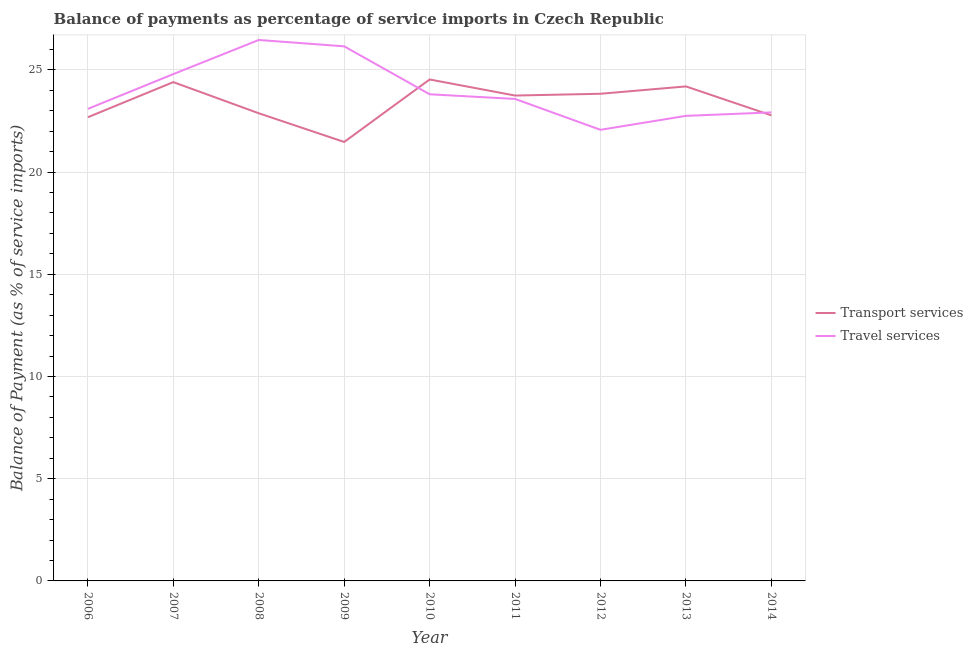How many different coloured lines are there?
Your answer should be compact. 2. Does the line corresponding to balance of payments of travel services intersect with the line corresponding to balance of payments of transport services?
Your answer should be compact. Yes. What is the balance of payments of travel services in 2010?
Your answer should be very brief. 23.8. Across all years, what is the maximum balance of payments of travel services?
Ensure brevity in your answer.  26.46. Across all years, what is the minimum balance of payments of travel services?
Provide a short and direct response. 22.07. What is the total balance of payments of travel services in the graph?
Your answer should be compact. 215.6. What is the difference between the balance of payments of travel services in 2008 and that in 2013?
Provide a short and direct response. 3.71. What is the difference between the balance of payments of transport services in 2012 and the balance of payments of travel services in 2011?
Offer a very short reply. 0.25. What is the average balance of payments of travel services per year?
Your answer should be compact. 23.96. In the year 2011, what is the difference between the balance of payments of travel services and balance of payments of transport services?
Provide a short and direct response. -0.17. In how many years, is the balance of payments of travel services greater than 24 %?
Offer a terse response. 3. What is the ratio of the balance of payments of transport services in 2007 to that in 2009?
Your answer should be compact. 1.14. Is the balance of payments of transport services in 2010 less than that in 2012?
Your response must be concise. No. Is the difference between the balance of payments of transport services in 2006 and 2008 greater than the difference between the balance of payments of travel services in 2006 and 2008?
Give a very brief answer. Yes. What is the difference between the highest and the second highest balance of payments of travel services?
Keep it short and to the point. 0.31. What is the difference between the highest and the lowest balance of payments of travel services?
Provide a short and direct response. 4.39. In how many years, is the balance of payments of transport services greater than the average balance of payments of transport services taken over all years?
Keep it short and to the point. 5. How many lines are there?
Your answer should be very brief. 2. How many years are there in the graph?
Keep it short and to the point. 9. What is the difference between two consecutive major ticks on the Y-axis?
Ensure brevity in your answer.  5. Are the values on the major ticks of Y-axis written in scientific E-notation?
Offer a very short reply. No. Does the graph contain grids?
Your response must be concise. Yes. Where does the legend appear in the graph?
Make the answer very short. Center right. How many legend labels are there?
Ensure brevity in your answer.  2. How are the legend labels stacked?
Your response must be concise. Vertical. What is the title of the graph?
Your response must be concise. Balance of payments as percentage of service imports in Czech Republic. Does "Quality of trade" appear as one of the legend labels in the graph?
Provide a short and direct response. No. What is the label or title of the Y-axis?
Give a very brief answer. Balance of Payment (as % of service imports). What is the Balance of Payment (as % of service imports) of Transport services in 2006?
Give a very brief answer. 22.68. What is the Balance of Payment (as % of service imports) of Travel services in 2006?
Offer a terse response. 23.09. What is the Balance of Payment (as % of service imports) of Transport services in 2007?
Keep it short and to the point. 24.4. What is the Balance of Payment (as % of service imports) in Travel services in 2007?
Make the answer very short. 24.79. What is the Balance of Payment (as % of service imports) of Transport services in 2008?
Offer a very short reply. 22.88. What is the Balance of Payment (as % of service imports) in Travel services in 2008?
Offer a terse response. 26.46. What is the Balance of Payment (as % of service imports) in Transport services in 2009?
Provide a succinct answer. 21.47. What is the Balance of Payment (as % of service imports) of Travel services in 2009?
Make the answer very short. 26.15. What is the Balance of Payment (as % of service imports) of Transport services in 2010?
Provide a succinct answer. 24.53. What is the Balance of Payment (as % of service imports) of Travel services in 2010?
Your answer should be compact. 23.8. What is the Balance of Payment (as % of service imports) of Transport services in 2011?
Make the answer very short. 23.74. What is the Balance of Payment (as % of service imports) in Travel services in 2011?
Make the answer very short. 23.58. What is the Balance of Payment (as % of service imports) in Transport services in 2012?
Keep it short and to the point. 23.83. What is the Balance of Payment (as % of service imports) in Travel services in 2012?
Make the answer very short. 22.07. What is the Balance of Payment (as % of service imports) in Transport services in 2013?
Make the answer very short. 24.19. What is the Balance of Payment (as % of service imports) in Travel services in 2013?
Your answer should be compact. 22.75. What is the Balance of Payment (as % of service imports) in Transport services in 2014?
Your answer should be compact. 22.77. What is the Balance of Payment (as % of service imports) in Travel services in 2014?
Make the answer very short. 22.92. Across all years, what is the maximum Balance of Payment (as % of service imports) in Transport services?
Offer a terse response. 24.53. Across all years, what is the maximum Balance of Payment (as % of service imports) of Travel services?
Keep it short and to the point. 26.46. Across all years, what is the minimum Balance of Payment (as % of service imports) in Transport services?
Ensure brevity in your answer.  21.47. Across all years, what is the minimum Balance of Payment (as % of service imports) in Travel services?
Your response must be concise. 22.07. What is the total Balance of Payment (as % of service imports) of Transport services in the graph?
Your response must be concise. 210.49. What is the total Balance of Payment (as % of service imports) of Travel services in the graph?
Give a very brief answer. 215.6. What is the difference between the Balance of Payment (as % of service imports) in Transport services in 2006 and that in 2007?
Offer a very short reply. -1.72. What is the difference between the Balance of Payment (as % of service imports) in Travel services in 2006 and that in 2007?
Offer a terse response. -1.7. What is the difference between the Balance of Payment (as % of service imports) of Transport services in 2006 and that in 2008?
Provide a short and direct response. -0.19. What is the difference between the Balance of Payment (as % of service imports) in Travel services in 2006 and that in 2008?
Give a very brief answer. -3.37. What is the difference between the Balance of Payment (as % of service imports) in Transport services in 2006 and that in 2009?
Your response must be concise. 1.21. What is the difference between the Balance of Payment (as % of service imports) in Travel services in 2006 and that in 2009?
Ensure brevity in your answer.  -3.06. What is the difference between the Balance of Payment (as % of service imports) in Transport services in 2006 and that in 2010?
Keep it short and to the point. -1.84. What is the difference between the Balance of Payment (as % of service imports) of Travel services in 2006 and that in 2010?
Make the answer very short. -0.71. What is the difference between the Balance of Payment (as % of service imports) in Transport services in 2006 and that in 2011?
Ensure brevity in your answer.  -1.06. What is the difference between the Balance of Payment (as % of service imports) of Travel services in 2006 and that in 2011?
Your answer should be very brief. -0.49. What is the difference between the Balance of Payment (as % of service imports) in Transport services in 2006 and that in 2012?
Ensure brevity in your answer.  -1.15. What is the difference between the Balance of Payment (as % of service imports) in Travel services in 2006 and that in 2012?
Keep it short and to the point. 1.02. What is the difference between the Balance of Payment (as % of service imports) of Transport services in 2006 and that in 2013?
Provide a short and direct response. -1.51. What is the difference between the Balance of Payment (as % of service imports) in Travel services in 2006 and that in 2013?
Offer a terse response. 0.34. What is the difference between the Balance of Payment (as % of service imports) in Transport services in 2006 and that in 2014?
Your answer should be compact. -0.09. What is the difference between the Balance of Payment (as % of service imports) of Travel services in 2006 and that in 2014?
Keep it short and to the point. 0.17. What is the difference between the Balance of Payment (as % of service imports) of Transport services in 2007 and that in 2008?
Ensure brevity in your answer.  1.52. What is the difference between the Balance of Payment (as % of service imports) of Travel services in 2007 and that in 2008?
Your response must be concise. -1.67. What is the difference between the Balance of Payment (as % of service imports) of Transport services in 2007 and that in 2009?
Your answer should be very brief. 2.93. What is the difference between the Balance of Payment (as % of service imports) of Travel services in 2007 and that in 2009?
Offer a terse response. -1.36. What is the difference between the Balance of Payment (as % of service imports) of Transport services in 2007 and that in 2010?
Make the answer very short. -0.13. What is the difference between the Balance of Payment (as % of service imports) in Travel services in 2007 and that in 2010?
Your answer should be very brief. 0.99. What is the difference between the Balance of Payment (as % of service imports) of Transport services in 2007 and that in 2011?
Your response must be concise. 0.66. What is the difference between the Balance of Payment (as % of service imports) in Travel services in 2007 and that in 2011?
Keep it short and to the point. 1.21. What is the difference between the Balance of Payment (as % of service imports) of Transport services in 2007 and that in 2012?
Keep it short and to the point. 0.57. What is the difference between the Balance of Payment (as % of service imports) in Travel services in 2007 and that in 2012?
Keep it short and to the point. 2.73. What is the difference between the Balance of Payment (as % of service imports) in Transport services in 2007 and that in 2013?
Provide a short and direct response. 0.21. What is the difference between the Balance of Payment (as % of service imports) of Travel services in 2007 and that in 2013?
Ensure brevity in your answer.  2.04. What is the difference between the Balance of Payment (as % of service imports) in Transport services in 2007 and that in 2014?
Make the answer very short. 1.63. What is the difference between the Balance of Payment (as % of service imports) in Travel services in 2007 and that in 2014?
Give a very brief answer. 1.87. What is the difference between the Balance of Payment (as % of service imports) of Transport services in 2008 and that in 2009?
Keep it short and to the point. 1.4. What is the difference between the Balance of Payment (as % of service imports) in Travel services in 2008 and that in 2009?
Keep it short and to the point. 0.31. What is the difference between the Balance of Payment (as % of service imports) of Transport services in 2008 and that in 2010?
Offer a terse response. -1.65. What is the difference between the Balance of Payment (as % of service imports) of Travel services in 2008 and that in 2010?
Provide a short and direct response. 2.66. What is the difference between the Balance of Payment (as % of service imports) in Transport services in 2008 and that in 2011?
Give a very brief answer. -0.87. What is the difference between the Balance of Payment (as % of service imports) of Travel services in 2008 and that in 2011?
Your answer should be compact. 2.88. What is the difference between the Balance of Payment (as % of service imports) of Transport services in 2008 and that in 2012?
Provide a succinct answer. -0.95. What is the difference between the Balance of Payment (as % of service imports) in Travel services in 2008 and that in 2012?
Offer a terse response. 4.39. What is the difference between the Balance of Payment (as % of service imports) in Transport services in 2008 and that in 2013?
Ensure brevity in your answer.  -1.31. What is the difference between the Balance of Payment (as % of service imports) in Travel services in 2008 and that in 2013?
Keep it short and to the point. 3.71. What is the difference between the Balance of Payment (as % of service imports) of Transport services in 2008 and that in 2014?
Offer a very short reply. 0.1. What is the difference between the Balance of Payment (as % of service imports) of Travel services in 2008 and that in 2014?
Your response must be concise. 3.54. What is the difference between the Balance of Payment (as % of service imports) of Transport services in 2009 and that in 2010?
Your answer should be very brief. -3.06. What is the difference between the Balance of Payment (as % of service imports) in Travel services in 2009 and that in 2010?
Your answer should be very brief. 2.34. What is the difference between the Balance of Payment (as % of service imports) in Transport services in 2009 and that in 2011?
Your answer should be very brief. -2.27. What is the difference between the Balance of Payment (as % of service imports) in Travel services in 2009 and that in 2011?
Offer a very short reply. 2.57. What is the difference between the Balance of Payment (as % of service imports) in Transport services in 2009 and that in 2012?
Your answer should be very brief. -2.36. What is the difference between the Balance of Payment (as % of service imports) of Travel services in 2009 and that in 2012?
Your response must be concise. 4.08. What is the difference between the Balance of Payment (as % of service imports) in Transport services in 2009 and that in 2013?
Provide a short and direct response. -2.72. What is the difference between the Balance of Payment (as % of service imports) of Travel services in 2009 and that in 2013?
Offer a very short reply. 3.4. What is the difference between the Balance of Payment (as % of service imports) of Transport services in 2009 and that in 2014?
Your response must be concise. -1.3. What is the difference between the Balance of Payment (as % of service imports) of Travel services in 2009 and that in 2014?
Offer a very short reply. 3.23. What is the difference between the Balance of Payment (as % of service imports) in Transport services in 2010 and that in 2011?
Ensure brevity in your answer.  0.79. What is the difference between the Balance of Payment (as % of service imports) in Travel services in 2010 and that in 2011?
Give a very brief answer. 0.23. What is the difference between the Balance of Payment (as % of service imports) of Transport services in 2010 and that in 2012?
Ensure brevity in your answer.  0.7. What is the difference between the Balance of Payment (as % of service imports) in Travel services in 2010 and that in 2012?
Offer a very short reply. 1.74. What is the difference between the Balance of Payment (as % of service imports) in Transport services in 2010 and that in 2013?
Provide a short and direct response. 0.34. What is the difference between the Balance of Payment (as % of service imports) of Travel services in 2010 and that in 2013?
Provide a short and direct response. 1.06. What is the difference between the Balance of Payment (as % of service imports) in Transport services in 2010 and that in 2014?
Your answer should be compact. 1.75. What is the difference between the Balance of Payment (as % of service imports) of Travel services in 2010 and that in 2014?
Give a very brief answer. 0.89. What is the difference between the Balance of Payment (as % of service imports) of Transport services in 2011 and that in 2012?
Your answer should be very brief. -0.09. What is the difference between the Balance of Payment (as % of service imports) in Travel services in 2011 and that in 2012?
Make the answer very short. 1.51. What is the difference between the Balance of Payment (as % of service imports) of Transport services in 2011 and that in 2013?
Provide a succinct answer. -0.45. What is the difference between the Balance of Payment (as % of service imports) of Travel services in 2011 and that in 2013?
Provide a short and direct response. 0.83. What is the difference between the Balance of Payment (as % of service imports) of Transport services in 2011 and that in 2014?
Your answer should be compact. 0.97. What is the difference between the Balance of Payment (as % of service imports) in Travel services in 2011 and that in 2014?
Keep it short and to the point. 0.66. What is the difference between the Balance of Payment (as % of service imports) of Transport services in 2012 and that in 2013?
Give a very brief answer. -0.36. What is the difference between the Balance of Payment (as % of service imports) in Travel services in 2012 and that in 2013?
Make the answer very short. -0.68. What is the difference between the Balance of Payment (as % of service imports) in Transport services in 2012 and that in 2014?
Provide a short and direct response. 1.06. What is the difference between the Balance of Payment (as % of service imports) of Travel services in 2012 and that in 2014?
Ensure brevity in your answer.  -0.85. What is the difference between the Balance of Payment (as % of service imports) of Transport services in 2013 and that in 2014?
Your answer should be compact. 1.42. What is the difference between the Balance of Payment (as % of service imports) of Travel services in 2013 and that in 2014?
Offer a very short reply. -0.17. What is the difference between the Balance of Payment (as % of service imports) in Transport services in 2006 and the Balance of Payment (as % of service imports) in Travel services in 2007?
Your response must be concise. -2.11. What is the difference between the Balance of Payment (as % of service imports) in Transport services in 2006 and the Balance of Payment (as % of service imports) in Travel services in 2008?
Offer a terse response. -3.78. What is the difference between the Balance of Payment (as % of service imports) of Transport services in 2006 and the Balance of Payment (as % of service imports) of Travel services in 2009?
Your answer should be compact. -3.47. What is the difference between the Balance of Payment (as % of service imports) of Transport services in 2006 and the Balance of Payment (as % of service imports) of Travel services in 2010?
Offer a very short reply. -1.12. What is the difference between the Balance of Payment (as % of service imports) of Transport services in 2006 and the Balance of Payment (as % of service imports) of Travel services in 2011?
Your answer should be very brief. -0.89. What is the difference between the Balance of Payment (as % of service imports) of Transport services in 2006 and the Balance of Payment (as % of service imports) of Travel services in 2012?
Your response must be concise. 0.62. What is the difference between the Balance of Payment (as % of service imports) of Transport services in 2006 and the Balance of Payment (as % of service imports) of Travel services in 2013?
Your response must be concise. -0.07. What is the difference between the Balance of Payment (as % of service imports) of Transport services in 2006 and the Balance of Payment (as % of service imports) of Travel services in 2014?
Ensure brevity in your answer.  -0.23. What is the difference between the Balance of Payment (as % of service imports) of Transport services in 2007 and the Balance of Payment (as % of service imports) of Travel services in 2008?
Keep it short and to the point. -2.06. What is the difference between the Balance of Payment (as % of service imports) of Transport services in 2007 and the Balance of Payment (as % of service imports) of Travel services in 2009?
Make the answer very short. -1.75. What is the difference between the Balance of Payment (as % of service imports) of Transport services in 2007 and the Balance of Payment (as % of service imports) of Travel services in 2010?
Keep it short and to the point. 0.59. What is the difference between the Balance of Payment (as % of service imports) in Transport services in 2007 and the Balance of Payment (as % of service imports) in Travel services in 2011?
Provide a succinct answer. 0.82. What is the difference between the Balance of Payment (as % of service imports) of Transport services in 2007 and the Balance of Payment (as % of service imports) of Travel services in 2012?
Provide a short and direct response. 2.33. What is the difference between the Balance of Payment (as % of service imports) of Transport services in 2007 and the Balance of Payment (as % of service imports) of Travel services in 2013?
Your answer should be very brief. 1.65. What is the difference between the Balance of Payment (as % of service imports) of Transport services in 2007 and the Balance of Payment (as % of service imports) of Travel services in 2014?
Keep it short and to the point. 1.48. What is the difference between the Balance of Payment (as % of service imports) of Transport services in 2008 and the Balance of Payment (as % of service imports) of Travel services in 2009?
Your answer should be very brief. -3.27. What is the difference between the Balance of Payment (as % of service imports) of Transport services in 2008 and the Balance of Payment (as % of service imports) of Travel services in 2010?
Your answer should be compact. -0.93. What is the difference between the Balance of Payment (as % of service imports) of Transport services in 2008 and the Balance of Payment (as % of service imports) of Travel services in 2011?
Provide a succinct answer. -0.7. What is the difference between the Balance of Payment (as % of service imports) in Transport services in 2008 and the Balance of Payment (as % of service imports) in Travel services in 2012?
Ensure brevity in your answer.  0.81. What is the difference between the Balance of Payment (as % of service imports) in Transport services in 2008 and the Balance of Payment (as % of service imports) in Travel services in 2013?
Provide a succinct answer. 0.13. What is the difference between the Balance of Payment (as % of service imports) in Transport services in 2008 and the Balance of Payment (as % of service imports) in Travel services in 2014?
Provide a short and direct response. -0.04. What is the difference between the Balance of Payment (as % of service imports) of Transport services in 2009 and the Balance of Payment (as % of service imports) of Travel services in 2010?
Offer a terse response. -2.33. What is the difference between the Balance of Payment (as % of service imports) in Transport services in 2009 and the Balance of Payment (as % of service imports) in Travel services in 2011?
Provide a succinct answer. -2.11. What is the difference between the Balance of Payment (as % of service imports) in Transport services in 2009 and the Balance of Payment (as % of service imports) in Travel services in 2012?
Keep it short and to the point. -0.59. What is the difference between the Balance of Payment (as % of service imports) in Transport services in 2009 and the Balance of Payment (as % of service imports) in Travel services in 2013?
Offer a very short reply. -1.28. What is the difference between the Balance of Payment (as % of service imports) of Transport services in 2009 and the Balance of Payment (as % of service imports) of Travel services in 2014?
Your response must be concise. -1.45. What is the difference between the Balance of Payment (as % of service imports) of Transport services in 2010 and the Balance of Payment (as % of service imports) of Travel services in 2011?
Provide a succinct answer. 0.95. What is the difference between the Balance of Payment (as % of service imports) in Transport services in 2010 and the Balance of Payment (as % of service imports) in Travel services in 2012?
Your answer should be compact. 2.46. What is the difference between the Balance of Payment (as % of service imports) of Transport services in 2010 and the Balance of Payment (as % of service imports) of Travel services in 2013?
Your response must be concise. 1.78. What is the difference between the Balance of Payment (as % of service imports) of Transport services in 2010 and the Balance of Payment (as % of service imports) of Travel services in 2014?
Give a very brief answer. 1.61. What is the difference between the Balance of Payment (as % of service imports) of Transport services in 2011 and the Balance of Payment (as % of service imports) of Travel services in 2012?
Your response must be concise. 1.68. What is the difference between the Balance of Payment (as % of service imports) in Transport services in 2011 and the Balance of Payment (as % of service imports) in Travel services in 2013?
Provide a succinct answer. 0.99. What is the difference between the Balance of Payment (as % of service imports) in Transport services in 2011 and the Balance of Payment (as % of service imports) in Travel services in 2014?
Give a very brief answer. 0.82. What is the difference between the Balance of Payment (as % of service imports) of Transport services in 2012 and the Balance of Payment (as % of service imports) of Travel services in 2013?
Keep it short and to the point. 1.08. What is the difference between the Balance of Payment (as % of service imports) of Transport services in 2012 and the Balance of Payment (as % of service imports) of Travel services in 2014?
Your answer should be very brief. 0.91. What is the difference between the Balance of Payment (as % of service imports) of Transport services in 2013 and the Balance of Payment (as % of service imports) of Travel services in 2014?
Ensure brevity in your answer.  1.27. What is the average Balance of Payment (as % of service imports) of Transport services per year?
Ensure brevity in your answer.  23.39. What is the average Balance of Payment (as % of service imports) in Travel services per year?
Offer a very short reply. 23.96. In the year 2006, what is the difference between the Balance of Payment (as % of service imports) of Transport services and Balance of Payment (as % of service imports) of Travel services?
Offer a very short reply. -0.41. In the year 2007, what is the difference between the Balance of Payment (as % of service imports) of Transport services and Balance of Payment (as % of service imports) of Travel services?
Ensure brevity in your answer.  -0.39. In the year 2008, what is the difference between the Balance of Payment (as % of service imports) in Transport services and Balance of Payment (as % of service imports) in Travel services?
Ensure brevity in your answer.  -3.58. In the year 2009, what is the difference between the Balance of Payment (as % of service imports) of Transport services and Balance of Payment (as % of service imports) of Travel services?
Provide a short and direct response. -4.68. In the year 2010, what is the difference between the Balance of Payment (as % of service imports) of Transport services and Balance of Payment (as % of service imports) of Travel services?
Offer a terse response. 0.72. In the year 2011, what is the difference between the Balance of Payment (as % of service imports) of Transport services and Balance of Payment (as % of service imports) of Travel services?
Keep it short and to the point. 0.17. In the year 2012, what is the difference between the Balance of Payment (as % of service imports) of Transport services and Balance of Payment (as % of service imports) of Travel services?
Your response must be concise. 1.76. In the year 2013, what is the difference between the Balance of Payment (as % of service imports) in Transport services and Balance of Payment (as % of service imports) in Travel services?
Ensure brevity in your answer.  1.44. In the year 2014, what is the difference between the Balance of Payment (as % of service imports) in Transport services and Balance of Payment (as % of service imports) in Travel services?
Make the answer very short. -0.14. What is the ratio of the Balance of Payment (as % of service imports) in Transport services in 2006 to that in 2007?
Ensure brevity in your answer.  0.93. What is the ratio of the Balance of Payment (as % of service imports) in Travel services in 2006 to that in 2007?
Make the answer very short. 0.93. What is the ratio of the Balance of Payment (as % of service imports) of Travel services in 2006 to that in 2008?
Ensure brevity in your answer.  0.87. What is the ratio of the Balance of Payment (as % of service imports) in Transport services in 2006 to that in 2009?
Offer a terse response. 1.06. What is the ratio of the Balance of Payment (as % of service imports) in Travel services in 2006 to that in 2009?
Your answer should be very brief. 0.88. What is the ratio of the Balance of Payment (as % of service imports) in Transport services in 2006 to that in 2010?
Offer a terse response. 0.92. What is the ratio of the Balance of Payment (as % of service imports) in Travel services in 2006 to that in 2010?
Your answer should be very brief. 0.97. What is the ratio of the Balance of Payment (as % of service imports) of Transport services in 2006 to that in 2011?
Your answer should be very brief. 0.96. What is the ratio of the Balance of Payment (as % of service imports) in Travel services in 2006 to that in 2011?
Your answer should be compact. 0.98. What is the ratio of the Balance of Payment (as % of service imports) of Transport services in 2006 to that in 2012?
Your answer should be very brief. 0.95. What is the ratio of the Balance of Payment (as % of service imports) of Travel services in 2006 to that in 2012?
Provide a succinct answer. 1.05. What is the ratio of the Balance of Payment (as % of service imports) in Transport services in 2006 to that in 2013?
Offer a terse response. 0.94. What is the ratio of the Balance of Payment (as % of service imports) of Travel services in 2006 to that in 2013?
Offer a very short reply. 1.02. What is the ratio of the Balance of Payment (as % of service imports) in Transport services in 2006 to that in 2014?
Your answer should be compact. 1. What is the ratio of the Balance of Payment (as % of service imports) of Travel services in 2006 to that in 2014?
Offer a terse response. 1.01. What is the ratio of the Balance of Payment (as % of service imports) in Transport services in 2007 to that in 2008?
Keep it short and to the point. 1.07. What is the ratio of the Balance of Payment (as % of service imports) of Travel services in 2007 to that in 2008?
Provide a short and direct response. 0.94. What is the ratio of the Balance of Payment (as % of service imports) of Transport services in 2007 to that in 2009?
Keep it short and to the point. 1.14. What is the ratio of the Balance of Payment (as % of service imports) of Travel services in 2007 to that in 2009?
Make the answer very short. 0.95. What is the ratio of the Balance of Payment (as % of service imports) of Travel services in 2007 to that in 2010?
Your response must be concise. 1.04. What is the ratio of the Balance of Payment (as % of service imports) of Transport services in 2007 to that in 2011?
Your answer should be compact. 1.03. What is the ratio of the Balance of Payment (as % of service imports) in Travel services in 2007 to that in 2011?
Ensure brevity in your answer.  1.05. What is the ratio of the Balance of Payment (as % of service imports) in Transport services in 2007 to that in 2012?
Provide a succinct answer. 1.02. What is the ratio of the Balance of Payment (as % of service imports) in Travel services in 2007 to that in 2012?
Offer a terse response. 1.12. What is the ratio of the Balance of Payment (as % of service imports) of Transport services in 2007 to that in 2013?
Provide a succinct answer. 1.01. What is the ratio of the Balance of Payment (as % of service imports) of Travel services in 2007 to that in 2013?
Keep it short and to the point. 1.09. What is the ratio of the Balance of Payment (as % of service imports) in Transport services in 2007 to that in 2014?
Give a very brief answer. 1.07. What is the ratio of the Balance of Payment (as % of service imports) of Travel services in 2007 to that in 2014?
Offer a terse response. 1.08. What is the ratio of the Balance of Payment (as % of service imports) of Transport services in 2008 to that in 2009?
Provide a short and direct response. 1.07. What is the ratio of the Balance of Payment (as % of service imports) in Travel services in 2008 to that in 2009?
Ensure brevity in your answer.  1.01. What is the ratio of the Balance of Payment (as % of service imports) of Transport services in 2008 to that in 2010?
Make the answer very short. 0.93. What is the ratio of the Balance of Payment (as % of service imports) of Travel services in 2008 to that in 2010?
Offer a very short reply. 1.11. What is the ratio of the Balance of Payment (as % of service imports) of Transport services in 2008 to that in 2011?
Offer a terse response. 0.96. What is the ratio of the Balance of Payment (as % of service imports) of Travel services in 2008 to that in 2011?
Offer a terse response. 1.12. What is the ratio of the Balance of Payment (as % of service imports) of Travel services in 2008 to that in 2012?
Your answer should be compact. 1.2. What is the ratio of the Balance of Payment (as % of service imports) in Transport services in 2008 to that in 2013?
Keep it short and to the point. 0.95. What is the ratio of the Balance of Payment (as % of service imports) of Travel services in 2008 to that in 2013?
Offer a terse response. 1.16. What is the ratio of the Balance of Payment (as % of service imports) in Travel services in 2008 to that in 2014?
Provide a short and direct response. 1.15. What is the ratio of the Balance of Payment (as % of service imports) in Transport services in 2009 to that in 2010?
Keep it short and to the point. 0.88. What is the ratio of the Balance of Payment (as % of service imports) in Travel services in 2009 to that in 2010?
Make the answer very short. 1.1. What is the ratio of the Balance of Payment (as % of service imports) of Transport services in 2009 to that in 2011?
Your answer should be compact. 0.9. What is the ratio of the Balance of Payment (as % of service imports) of Travel services in 2009 to that in 2011?
Ensure brevity in your answer.  1.11. What is the ratio of the Balance of Payment (as % of service imports) of Transport services in 2009 to that in 2012?
Offer a terse response. 0.9. What is the ratio of the Balance of Payment (as % of service imports) of Travel services in 2009 to that in 2012?
Ensure brevity in your answer.  1.19. What is the ratio of the Balance of Payment (as % of service imports) of Transport services in 2009 to that in 2013?
Make the answer very short. 0.89. What is the ratio of the Balance of Payment (as % of service imports) in Travel services in 2009 to that in 2013?
Your response must be concise. 1.15. What is the ratio of the Balance of Payment (as % of service imports) of Transport services in 2009 to that in 2014?
Your response must be concise. 0.94. What is the ratio of the Balance of Payment (as % of service imports) of Travel services in 2009 to that in 2014?
Make the answer very short. 1.14. What is the ratio of the Balance of Payment (as % of service imports) in Transport services in 2010 to that in 2011?
Give a very brief answer. 1.03. What is the ratio of the Balance of Payment (as % of service imports) in Travel services in 2010 to that in 2011?
Provide a succinct answer. 1.01. What is the ratio of the Balance of Payment (as % of service imports) in Transport services in 2010 to that in 2012?
Offer a terse response. 1.03. What is the ratio of the Balance of Payment (as % of service imports) in Travel services in 2010 to that in 2012?
Keep it short and to the point. 1.08. What is the ratio of the Balance of Payment (as % of service imports) of Travel services in 2010 to that in 2013?
Your response must be concise. 1.05. What is the ratio of the Balance of Payment (as % of service imports) in Transport services in 2010 to that in 2014?
Provide a succinct answer. 1.08. What is the ratio of the Balance of Payment (as % of service imports) in Travel services in 2010 to that in 2014?
Make the answer very short. 1.04. What is the ratio of the Balance of Payment (as % of service imports) in Travel services in 2011 to that in 2012?
Ensure brevity in your answer.  1.07. What is the ratio of the Balance of Payment (as % of service imports) in Transport services in 2011 to that in 2013?
Your response must be concise. 0.98. What is the ratio of the Balance of Payment (as % of service imports) in Travel services in 2011 to that in 2013?
Make the answer very short. 1.04. What is the ratio of the Balance of Payment (as % of service imports) of Transport services in 2011 to that in 2014?
Offer a terse response. 1.04. What is the ratio of the Balance of Payment (as % of service imports) of Travel services in 2011 to that in 2014?
Keep it short and to the point. 1.03. What is the ratio of the Balance of Payment (as % of service imports) of Transport services in 2012 to that in 2013?
Ensure brevity in your answer.  0.99. What is the ratio of the Balance of Payment (as % of service imports) in Travel services in 2012 to that in 2013?
Provide a succinct answer. 0.97. What is the ratio of the Balance of Payment (as % of service imports) of Transport services in 2012 to that in 2014?
Your answer should be very brief. 1.05. What is the ratio of the Balance of Payment (as % of service imports) of Travel services in 2012 to that in 2014?
Ensure brevity in your answer.  0.96. What is the ratio of the Balance of Payment (as % of service imports) of Transport services in 2013 to that in 2014?
Make the answer very short. 1.06. What is the difference between the highest and the second highest Balance of Payment (as % of service imports) in Transport services?
Give a very brief answer. 0.13. What is the difference between the highest and the second highest Balance of Payment (as % of service imports) of Travel services?
Your answer should be compact. 0.31. What is the difference between the highest and the lowest Balance of Payment (as % of service imports) in Transport services?
Ensure brevity in your answer.  3.06. What is the difference between the highest and the lowest Balance of Payment (as % of service imports) of Travel services?
Offer a terse response. 4.39. 